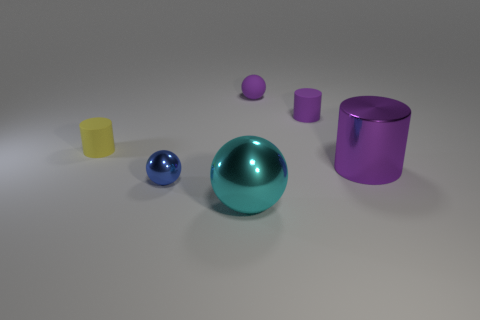How many blue objects are metal objects or tiny metallic things?
Your answer should be very brief. 1. What size is the cylinder to the right of the tiny matte thing right of the tiny purple sphere behind the yellow rubber cylinder?
Give a very brief answer. Large. What is the size of the other metal object that is the same shape as the yellow object?
Your answer should be very brief. Large. How many small things are balls or purple rubber things?
Make the answer very short. 3. Do the purple cylinder that is behind the yellow rubber thing and the small cylinder on the left side of the tiny matte sphere have the same material?
Your answer should be very brief. Yes. There is a big object that is left of the large purple metal cylinder; what is it made of?
Offer a very short reply. Metal. How many matte things are large cyan things or large green balls?
Make the answer very short. 0. There is a sphere in front of the tiny object in front of the yellow rubber object; what is its color?
Give a very brief answer. Cyan. Is the material of the cyan sphere the same as the tiny sphere to the right of the tiny blue thing?
Give a very brief answer. No. What is the color of the cylinder in front of the cylinder left of the large object to the left of the metallic cylinder?
Give a very brief answer. Purple. 